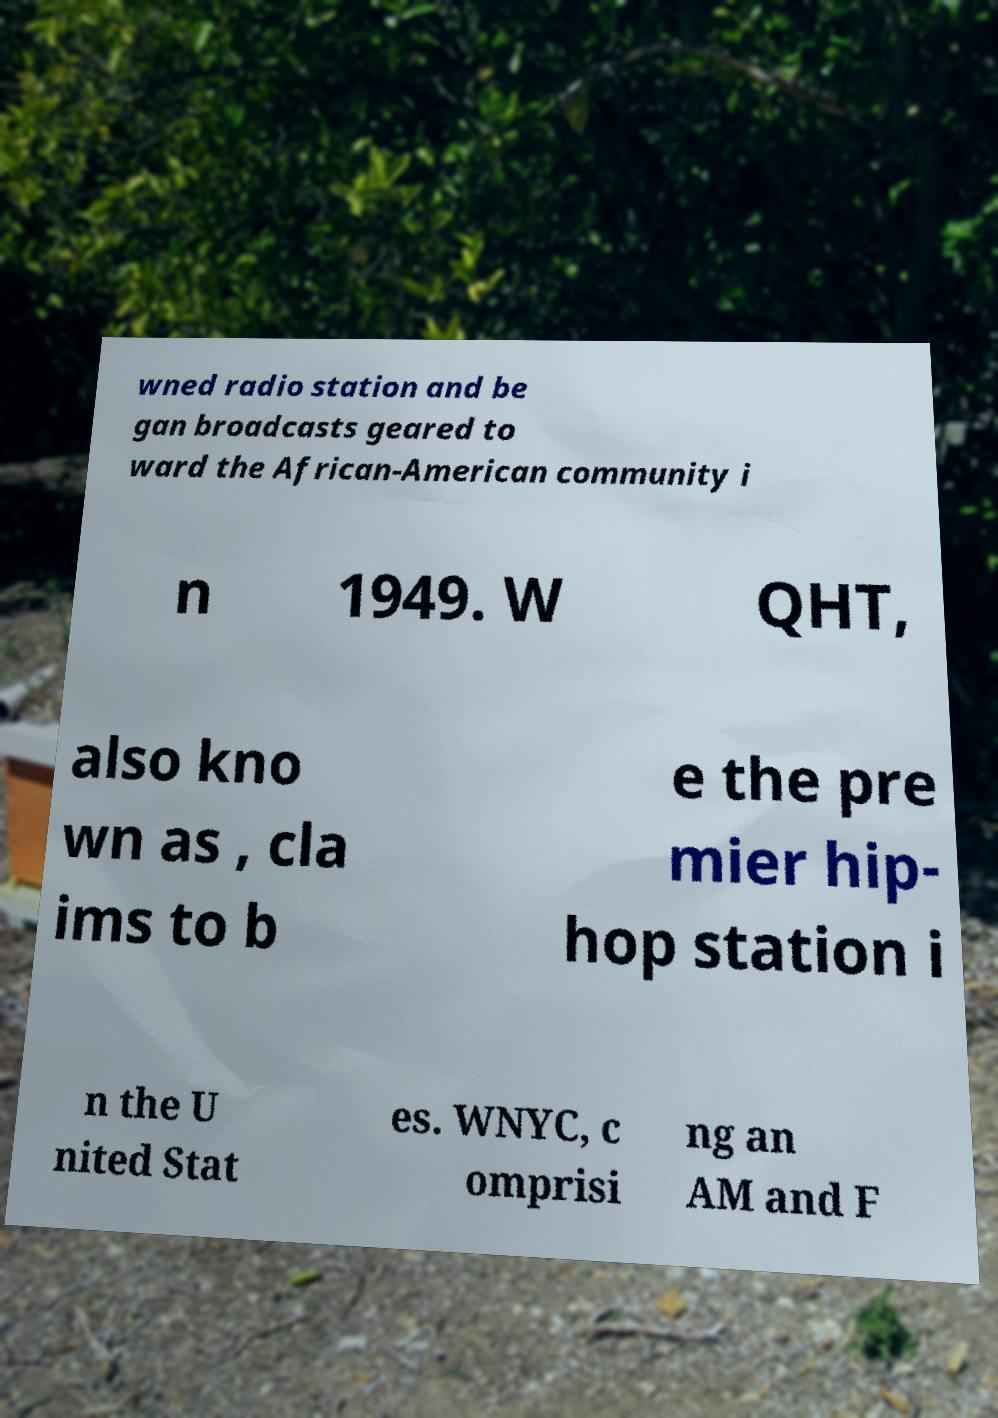Could you extract and type out the text from this image? wned radio station and be gan broadcasts geared to ward the African-American community i n 1949. W QHT, also kno wn as , cla ims to b e the pre mier hip- hop station i n the U nited Stat es. WNYC, c omprisi ng an AM and F 